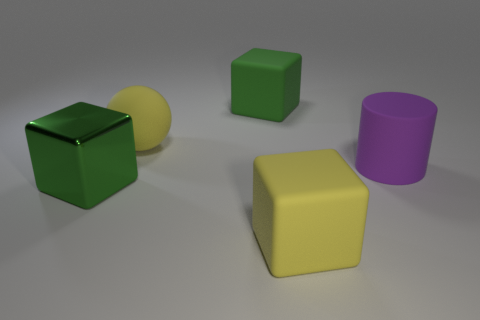Is the green block that is behind the purple matte thing made of the same material as the yellow object behind the big yellow matte block?
Provide a succinct answer. Yes. There is a yellow cube; are there any metallic things in front of it?
Provide a short and direct response. No. How many red objects are big metal cubes or rubber things?
Provide a succinct answer. 0. Are the large cylinder and the yellow object that is in front of the large purple cylinder made of the same material?
Your response must be concise. Yes. What is the size of the yellow matte object that is the same shape as the big metallic object?
Give a very brief answer. Large. What is the material of the big sphere?
Your answer should be compact. Rubber. What material is the purple object in front of the yellow rubber object that is behind the big green object that is in front of the big yellow rubber sphere?
Offer a terse response. Rubber. There is a green cube in front of the purple thing; is its size the same as the yellow rubber object in front of the green metal cube?
Provide a short and direct response. Yes. How many other objects are the same material as the purple thing?
Make the answer very short. 3. What number of shiny objects are either cubes or big blue spheres?
Your answer should be very brief. 1. 